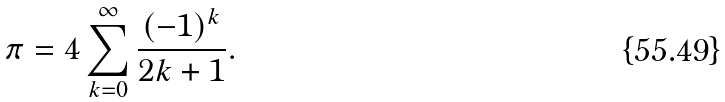<formula> <loc_0><loc_0><loc_500><loc_500>\pi = 4 \sum _ { k = 0 } ^ { \infty } \frac { ( - 1 ) ^ { k } } { 2 k + 1 } .</formula> 